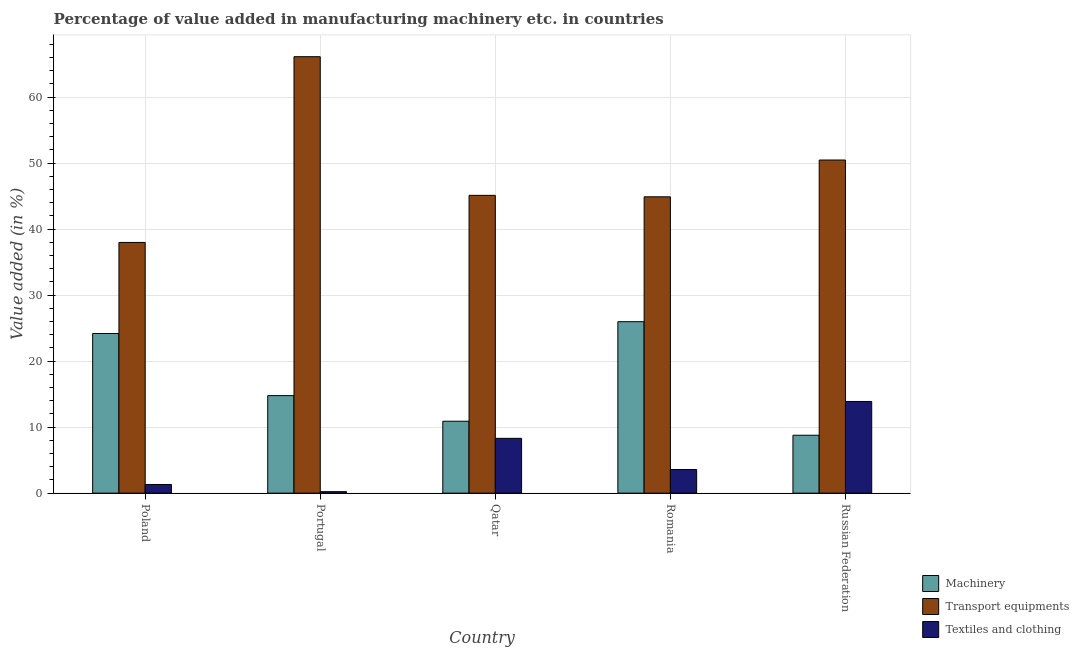How many different coloured bars are there?
Provide a succinct answer. 3. How many groups of bars are there?
Ensure brevity in your answer.  5. Are the number of bars per tick equal to the number of legend labels?
Give a very brief answer. Yes. Are the number of bars on each tick of the X-axis equal?
Provide a short and direct response. Yes. What is the label of the 4th group of bars from the left?
Your response must be concise. Romania. In how many cases, is the number of bars for a given country not equal to the number of legend labels?
Make the answer very short. 0. What is the value added in manufacturing textile and clothing in Romania?
Your response must be concise. 3.58. Across all countries, what is the maximum value added in manufacturing transport equipments?
Make the answer very short. 66.13. Across all countries, what is the minimum value added in manufacturing transport equipments?
Provide a short and direct response. 37.99. In which country was the value added in manufacturing transport equipments maximum?
Give a very brief answer. Portugal. In which country was the value added in manufacturing machinery minimum?
Offer a very short reply. Russian Federation. What is the total value added in manufacturing transport equipments in the graph?
Give a very brief answer. 244.63. What is the difference between the value added in manufacturing textile and clothing in Portugal and that in Russian Federation?
Keep it short and to the point. -13.67. What is the difference between the value added in manufacturing transport equipments in Poland and the value added in manufacturing textile and clothing in Qatar?
Give a very brief answer. 29.68. What is the average value added in manufacturing machinery per country?
Offer a terse response. 16.92. What is the difference between the value added in manufacturing machinery and value added in manufacturing transport equipments in Russian Federation?
Provide a succinct answer. -41.7. In how many countries, is the value added in manufacturing textile and clothing greater than 18 %?
Your answer should be compact. 0. What is the ratio of the value added in manufacturing machinery in Poland to that in Russian Federation?
Provide a succinct answer. 2.76. Is the value added in manufacturing machinery in Portugal less than that in Qatar?
Offer a terse response. No. Is the difference between the value added in manufacturing transport equipments in Poland and Portugal greater than the difference between the value added in manufacturing textile and clothing in Poland and Portugal?
Provide a succinct answer. No. What is the difference between the highest and the second highest value added in manufacturing transport equipments?
Offer a very short reply. 15.66. What is the difference between the highest and the lowest value added in manufacturing textile and clothing?
Keep it short and to the point. 13.67. In how many countries, is the value added in manufacturing textile and clothing greater than the average value added in manufacturing textile and clothing taken over all countries?
Provide a succinct answer. 2. Is the sum of the value added in manufacturing machinery in Poland and Russian Federation greater than the maximum value added in manufacturing textile and clothing across all countries?
Make the answer very short. Yes. What does the 2nd bar from the left in Poland represents?
Keep it short and to the point. Transport equipments. What does the 2nd bar from the right in Russian Federation represents?
Offer a terse response. Transport equipments. How many bars are there?
Offer a very short reply. 15. How many countries are there in the graph?
Keep it short and to the point. 5. What is the difference between two consecutive major ticks on the Y-axis?
Ensure brevity in your answer.  10. Are the values on the major ticks of Y-axis written in scientific E-notation?
Provide a succinct answer. No. Does the graph contain any zero values?
Your response must be concise. No. Where does the legend appear in the graph?
Give a very brief answer. Bottom right. How many legend labels are there?
Your answer should be compact. 3. How are the legend labels stacked?
Keep it short and to the point. Vertical. What is the title of the graph?
Provide a succinct answer. Percentage of value added in manufacturing machinery etc. in countries. What is the label or title of the Y-axis?
Keep it short and to the point. Value added (in %). What is the Value added (in %) in Machinery in Poland?
Your response must be concise. 24.19. What is the Value added (in %) of Transport equipments in Poland?
Offer a very short reply. 37.99. What is the Value added (in %) of Textiles and clothing in Poland?
Keep it short and to the point. 1.31. What is the Value added (in %) of Machinery in Portugal?
Provide a succinct answer. 14.78. What is the Value added (in %) in Transport equipments in Portugal?
Keep it short and to the point. 66.13. What is the Value added (in %) in Textiles and clothing in Portugal?
Your answer should be compact. 0.23. What is the Value added (in %) in Machinery in Qatar?
Your answer should be compact. 10.9. What is the Value added (in %) of Transport equipments in Qatar?
Provide a succinct answer. 45.12. What is the Value added (in %) in Textiles and clothing in Qatar?
Offer a very short reply. 8.3. What is the Value added (in %) in Machinery in Romania?
Provide a succinct answer. 25.98. What is the Value added (in %) of Transport equipments in Romania?
Ensure brevity in your answer.  44.9. What is the Value added (in %) in Textiles and clothing in Romania?
Your response must be concise. 3.58. What is the Value added (in %) in Machinery in Russian Federation?
Your answer should be very brief. 8.77. What is the Value added (in %) in Transport equipments in Russian Federation?
Ensure brevity in your answer.  50.48. What is the Value added (in %) of Textiles and clothing in Russian Federation?
Offer a very short reply. 13.89. Across all countries, what is the maximum Value added (in %) of Machinery?
Ensure brevity in your answer.  25.98. Across all countries, what is the maximum Value added (in %) of Transport equipments?
Provide a succinct answer. 66.13. Across all countries, what is the maximum Value added (in %) in Textiles and clothing?
Ensure brevity in your answer.  13.89. Across all countries, what is the minimum Value added (in %) of Machinery?
Offer a terse response. 8.77. Across all countries, what is the minimum Value added (in %) of Transport equipments?
Ensure brevity in your answer.  37.99. Across all countries, what is the minimum Value added (in %) of Textiles and clothing?
Give a very brief answer. 0.23. What is the total Value added (in %) of Machinery in the graph?
Your answer should be compact. 84.62. What is the total Value added (in %) in Transport equipments in the graph?
Make the answer very short. 244.62. What is the total Value added (in %) of Textiles and clothing in the graph?
Your answer should be very brief. 27.31. What is the difference between the Value added (in %) in Machinery in Poland and that in Portugal?
Provide a succinct answer. 9.41. What is the difference between the Value added (in %) in Transport equipments in Poland and that in Portugal?
Your answer should be compact. -28.15. What is the difference between the Value added (in %) in Textiles and clothing in Poland and that in Portugal?
Your answer should be compact. 1.09. What is the difference between the Value added (in %) of Machinery in Poland and that in Qatar?
Your response must be concise. 13.29. What is the difference between the Value added (in %) in Transport equipments in Poland and that in Qatar?
Offer a terse response. -7.14. What is the difference between the Value added (in %) of Textiles and clothing in Poland and that in Qatar?
Your answer should be very brief. -6.99. What is the difference between the Value added (in %) of Machinery in Poland and that in Romania?
Make the answer very short. -1.79. What is the difference between the Value added (in %) of Transport equipments in Poland and that in Romania?
Offer a terse response. -6.92. What is the difference between the Value added (in %) of Textiles and clothing in Poland and that in Romania?
Provide a short and direct response. -2.26. What is the difference between the Value added (in %) of Machinery in Poland and that in Russian Federation?
Make the answer very short. 15.42. What is the difference between the Value added (in %) of Transport equipments in Poland and that in Russian Federation?
Make the answer very short. -12.49. What is the difference between the Value added (in %) of Textiles and clothing in Poland and that in Russian Federation?
Offer a terse response. -12.58. What is the difference between the Value added (in %) in Machinery in Portugal and that in Qatar?
Ensure brevity in your answer.  3.88. What is the difference between the Value added (in %) of Transport equipments in Portugal and that in Qatar?
Keep it short and to the point. 21.01. What is the difference between the Value added (in %) of Textiles and clothing in Portugal and that in Qatar?
Your answer should be very brief. -8.08. What is the difference between the Value added (in %) in Machinery in Portugal and that in Romania?
Provide a short and direct response. -11.2. What is the difference between the Value added (in %) in Transport equipments in Portugal and that in Romania?
Keep it short and to the point. 21.23. What is the difference between the Value added (in %) in Textiles and clothing in Portugal and that in Romania?
Your answer should be very brief. -3.35. What is the difference between the Value added (in %) of Machinery in Portugal and that in Russian Federation?
Your response must be concise. 6. What is the difference between the Value added (in %) in Transport equipments in Portugal and that in Russian Federation?
Your answer should be compact. 15.66. What is the difference between the Value added (in %) of Textiles and clothing in Portugal and that in Russian Federation?
Provide a short and direct response. -13.67. What is the difference between the Value added (in %) in Machinery in Qatar and that in Romania?
Make the answer very short. -15.08. What is the difference between the Value added (in %) in Transport equipments in Qatar and that in Romania?
Your response must be concise. 0.22. What is the difference between the Value added (in %) of Textiles and clothing in Qatar and that in Romania?
Your response must be concise. 4.73. What is the difference between the Value added (in %) in Machinery in Qatar and that in Russian Federation?
Offer a very short reply. 2.12. What is the difference between the Value added (in %) in Transport equipments in Qatar and that in Russian Federation?
Provide a short and direct response. -5.35. What is the difference between the Value added (in %) in Textiles and clothing in Qatar and that in Russian Federation?
Your response must be concise. -5.59. What is the difference between the Value added (in %) of Machinery in Romania and that in Russian Federation?
Your answer should be compact. 17.21. What is the difference between the Value added (in %) in Transport equipments in Romania and that in Russian Federation?
Ensure brevity in your answer.  -5.57. What is the difference between the Value added (in %) of Textiles and clothing in Romania and that in Russian Federation?
Offer a very short reply. -10.31. What is the difference between the Value added (in %) of Machinery in Poland and the Value added (in %) of Transport equipments in Portugal?
Provide a short and direct response. -41.94. What is the difference between the Value added (in %) in Machinery in Poland and the Value added (in %) in Textiles and clothing in Portugal?
Give a very brief answer. 23.97. What is the difference between the Value added (in %) in Transport equipments in Poland and the Value added (in %) in Textiles and clothing in Portugal?
Offer a very short reply. 37.76. What is the difference between the Value added (in %) of Machinery in Poland and the Value added (in %) of Transport equipments in Qatar?
Offer a very short reply. -20.93. What is the difference between the Value added (in %) in Machinery in Poland and the Value added (in %) in Textiles and clothing in Qatar?
Make the answer very short. 15.89. What is the difference between the Value added (in %) in Transport equipments in Poland and the Value added (in %) in Textiles and clothing in Qatar?
Your answer should be very brief. 29.68. What is the difference between the Value added (in %) in Machinery in Poland and the Value added (in %) in Transport equipments in Romania?
Your answer should be compact. -20.71. What is the difference between the Value added (in %) of Machinery in Poland and the Value added (in %) of Textiles and clothing in Romania?
Provide a succinct answer. 20.61. What is the difference between the Value added (in %) of Transport equipments in Poland and the Value added (in %) of Textiles and clothing in Romania?
Ensure brevity in your answer.  34.41. What is the difference between the Value added (in %) of Machinery in Poland and the Value added (in %) of Transport equipments in Russian Federation?
Your answer should be compact. -26.29. What is the difference between the Value added (in %) of Transport equipments in Poland and the Value added (in %) of Textiles and clothing in Russian Federation?
Make the answer very short. 24.1. What is the difference between the Value added (in %) in Machinery in Portugal and the Value added (in %) in Transport equipments in Qatar?
Offer a very short reply. -30.35. What is the difference between the Value added (in %) in Machinery in Portugal and the Value added (in %) in Textiles and clothing in Qatar?
Provide a short and direct response. 6.47. What is the difference between the Value added (in %) in Transport equipments in Portugal and the Value added (in %) in Textiles and clothing in Qatar?
Make the answer very short. 57.83. What is the difference between the Value added (in %) in Machinery in Portugal and the Value added (in %) in Transport equipments in Romania?
Provide a short and direct response. -30.12. What is the difference between the Value added (in %) in Machinery in Portugal and the Value added (in %) in Textiles and clothing in Romania?
Provide a short and direct response. 11.2. What is the difference between the Value added (in %) in Transport equipments in Portugal and the Value added (in %) in Textiles and clothing in Romania?
Ensure brevity in your answer.  62.56. What is the difference between the Value added (in %) in Machinery in Portugal and the Value added (in %) in Transport equipments in Russian Federation?
Give a very brief answer. -35.7. What is the difference between the Value added (in %) of Machinery in Portugal and the Value added (in %) of Textiles and clothing in Russian Federation?
Provide a succinct answer. 0.89. What is the difference between the Value added (in %) in Transport equipments in Portugal and the Value added (in %) in Textiles and clothing in Russian Federation?
Your answer should be compact. 52.24. What is the difference between the Value added (in %) in Machinery in Qatar and the Value added (in %) in Transport equipments in Romania?
Your answer should be compact. -34.01. What is the difference between the Value added (in %) of Machinery in Qatar and the Value added (in %) of Textiles and clothing in Romania?
Provide a short and direct response. 7.32. What is the difference between the Value added (in %) in Transport equipments in Qatar and the Value added (in %) in Textiles and clothing in Romania?
Provide a succinct answer. 41.55. What is the difference between the Value added (in %) in Machinery in Qatar and the Value added (in %) in Transport equipments in Russian Federation?
Give a very brief answer. -39.58. What is the difference between the Value added (in %) in Machinery in Qatar and the Value added (in %) in Textiles and clothing in Russian Federation?
Your answer should be compact. -2.99. What is the difference between the Value added (in %) of Transport equipments in Qatar and the Value added (in %) of Textiles and clothing in Russian Federation?
Your response must be concise. 31.23. What is the difference between the Value added (in %) in Machinery in Romania and the Value added (in %) in Transport equipments in Russian Federation?
Your response must be concise. -24.5. What is the difference between the Value added (in %) of Machinery in Romania and the Value added (in %) of Textiles and clothing in Russian Federation?
Your answer should be very brief. 12.09. What is the difference between the Value added (in %) of Transport equipments in Romania and the Value added (in %) of Textiles and clothing in Russian Federation?
Your answer should be compact. 31.01. What is the average Value added (in %) of Machinery per country?
Make the answer very short. 16.92. What is the average Value added (in %) in Transport equipments per country?
Make the answer very short. 48.92. What is the average Value added (in %) in Textiles and clothing per country?
Keep it short and to the point. 5.46. What is the difference between the Value added (in %) in Machinery and Value added (in %) in Transport equipments in Poland?
Your response must be concise. -13.8. What is the difference between the Value added (in %) of Machinery and Value added (in %) of Textiles and clothing in Poland?
Your answer should be compact. 22.88. What is the difference between the Value added (in %) of Transport equipments and Value added (in %) of Textiles and clothing in Poland?
Keep it short and to the point. 36.67. What is the difference between the Value added (in %) in Machinery and Value added (in %) in Transport equipments in Portugal?
Make the answer very short. -51.36. What is the difference between the Value added (in %) of Machinery and Value added (in %) of Textiles and clothing in Portugal?
Provide a succinct answer. 14.55. What is the difference between the Value added (in %) in Transport equipments and Value added (in %) in Textiles and clothing in Portugal?
Provide a short and direct response. 65.91. What is the difference between the Value added (in %) of Machinery and Value added (in %) of Transport equipments in Qatar?
Offer a terse response. -34.23. What is the difference between the Value added (in %) in Machinery and Value added (in %) in Textiles and clothing in Qatar?
Ensure brevity in your answer.  2.59. What is the difference between the Value added (in %) in Transport equipments and Value added (in %) in Textiles and clothing in Qatar?
Provide a succinct answer. 36.82. What is the difference between the Value added (in %) in Machinery and Value added (in %) in Transport equipments in Romania?
Offer a very short reply. -18.92. What is the difference between the Value added (in %) in Machinery and Value added (in %) in Textiles and clothing in Romania?
Your answer should be compact. 22.4. What is the difference between the Value added (in %) of Transport equipments and Value added (in %) of Textiles and clothing in Romania?
Provide a succinct answer. 41.32. What is the difference between the Value added (in %) in Machinery and Value added (in %) in Transport equipments in Russian Federation?
Your response must be concise. -41.7. What is the difference between the Value added (in %) in Machinery and Value added (in %) in Textiles and clothing in Russian Federation?
Ensure brevity in your answer.  -5.12. What is the difference between the Value added (in %) of Transport equipments and Value added (in %) of Textiles and clothing in Russian Federation?
Offer a terse response. 36.59. What is the ratio of the Value added (in %) in Machinery in Poland to that in Portugal?
Provide a succinct answer. 1.64. What is the ratio of the Value added (in %) of Transport equipments in Poland to that in Portugal?
Provide a short and direct response. 0.57. What is the ratio of the Value added (in %) in Textiles and clothing in Poland to that in Portugal?
Offer a very short reply. 5.84. What is the ratio of the Value added (in %) of Machinery in Poland to that in Qatar?
Ensure brevity in your answer.  2.22. What is the ratio of the Value added (in %) of Transport equipments in Poland to that in Qatar?
Your answer should be very brief. 0.84. What is the ratio of the Value added (in %) of Textiles and clothing in Poland to that in Qatar?
Offer a terse response. 0.16. What is the ratio of the Value added (in %) in Machinery in Poland to that in Romania?
Your answer should be compact. 0.93. What is the ratio of the Value added (in %) in Transport equipments in Poland to that in Romania?
Provide a succinct answer. 0.85. What is the ratio of the Value added (in %) in Textiles and clothing in Poland to that in Romania?
Your answer should be compact. 0.37. What is the ratio of the Value added (in %) in Machinery in Poland to that in Russian Federation?
Provide a succinct answer. 2.76. What is the ratio of the Value added (in %) of Transport equipments in Poland to that in Russian Federation?
Offer a very short reply. 0.75. What is the ratio of the Value added (in %) in Textiles and clothing in Poland to that in Russian Federation?
Give a very brief answer. 0.09. What is the ratio of the Value added (in %) in Machinery in Portugal to that in Qatar?
Make the answer very short. 1.36. What is the ratio of the Value added (in %) of Transport equipments in Portugal to that in Qatar?
Your answer should be compact. 1.47. What is the ratio of the Value added (in %) of Textiles and clothing in Portugal to that in Qatar?
Offer a terse response. 0.03. What is the ratio of the Value added (in %) in Machinery in Portugal to that in Romania?
Your response must be concise. 0.57. What is the ratio of the Value added (in %) in Transport equipments in Portugal to that in Romania?
Provide a succinct answer. 1.47. What is the ratio of the Value added (in %) of Textiles and clothing in Portugal to that in Romania?
Keep it short and to the point. 0.06. What is the ratio of the Value added (in %) of Machinery in Portugal to that in Russian Federation?
Make the answer very short. 1.68. What is the ratio of the Value added (in %) in Transport equipments in Portugal to that in Russian Federation?
Offer a terse response. 1.31. What is the ratio of the Value added (in %) in Textiles and clothing in Portugal to that in Russian Federation?
Provide a succinct answer. 0.02. What is the ratio of the Value added (in %) of Machinery in Qatar to that in Romania?
Make the answer very short. 0.42. What is the ratio of the Value added (in %) in Transport equipments in Qatar to that in Romania?
Your answer should be compact. 1. What is the ratio of the Value added (in %) of Textiles and clothing in Qatar to that in Romania?
Your response must be concise. 2.32. What is the ratio of the Value added (in %) in Machinery in Qatar to that in Russian Federation?
Give a very brief answer. 1.24. What is the ratio of the Value added (in %) of Transport equipments in Qatar to that in Russian Federation?
Give a very brief answer. 0.89. What is the ratio of the Value added (in %) of Textiles and clothing in Qatar to that in Russian Federation?
Your answer should be very brief. 0.6. What is the ratio of the Value added (in %) of Machinery in Romania to that in Russian Federation?
Your answer should be compact. 2.96. What is the ratio of the Value added (in %) in Transport equipments in Romania to that in Russian Federation?
Provide a succinct answer. 0.89. What is the ratio of the Value added (in %) of Textiles and clothing in Romania to that in Russian Federation?
Provide a short and direct response. 0.26. What is the difference between the highest and the second highest Value added (in %) of Machinery?
Offer a very short reply. 1.79. What is the difference between the highest and the second highest Value added (in %) of Transport equipments?
Provide a succinct answer. 15.66. What is the difference between the highest and the second highest Value added (in %) of Textiles and clothing?
Provide a succinct answer. 5.59. What is the difference between the highest and the lowest Value added (in %) of Machinery?
Provide a succinct answer. 17.21. What is the difference between the highest and the lowest Value added (in %) of Transport equipments?
Give a very brief answer. 28.15. What is the difference between the highest and the lowest Value added (in %) of Textiles and clothing?
Give a very brief answer. 13.67. 